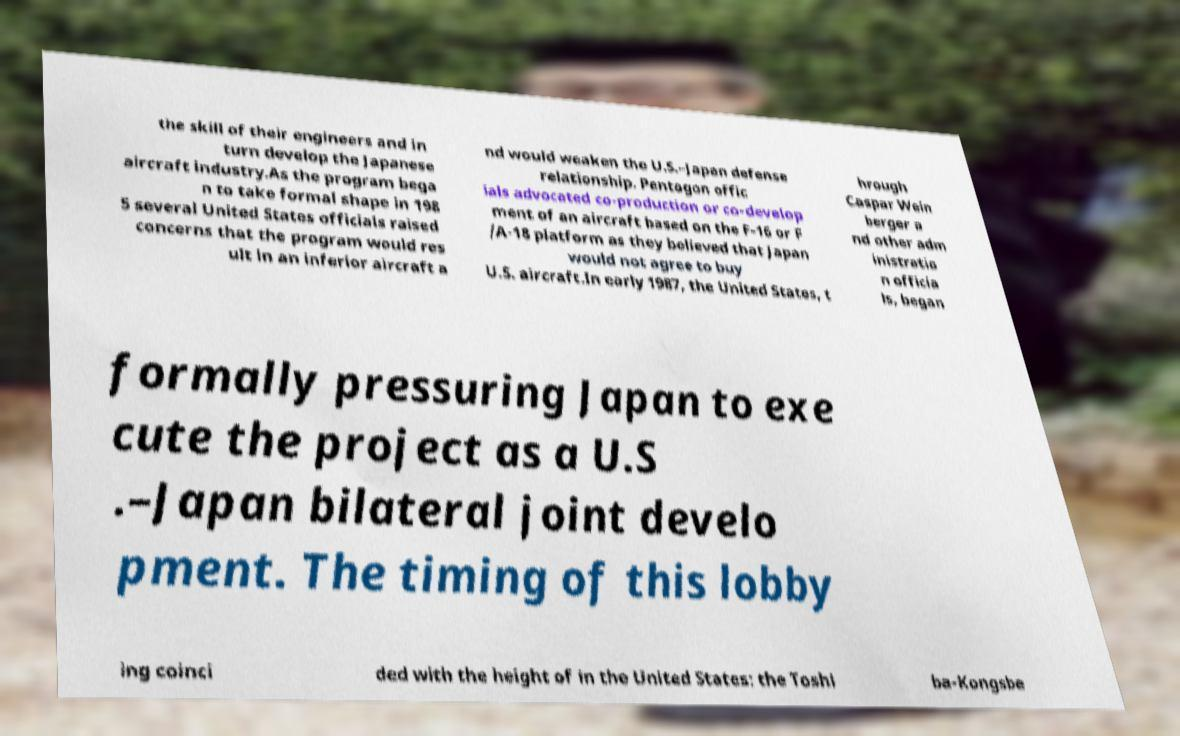I need the written content from this picture converted into text. Can you do that? the skill of their engineers and in turn develop the Japanese aircraft industry.As the program bega n to take formal shape in 198 5 several United States officials raised concerns that the program would res ult in an inferior aircraft a nd would weaken the U.S.–Japan defense relationship. Pentagon offic ials advocated co-production or co-develop ment of an aircraft based on the F-16 or F /A-18 platform as they believed that Japan would not agree to buy U.S. aircraft.In early 1987, the United States, t hrough Caspar Wein berger a nd other adm inistratio n officia ls, began formally pressuring Japan to exe cute the project as a U.S .–Japan bilateral joint develo pment. The timing of this lobby ing coinci ded with the height of in the United States: the Toshi ba-Kongsbe 